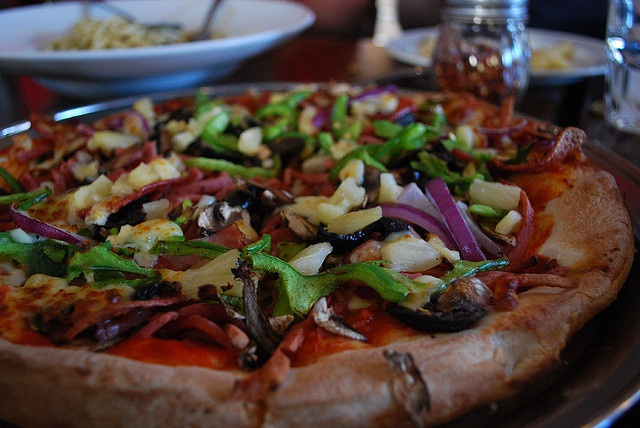Describe the objects in this image and their specific colors. I can see dining table in black, maroon, gray, and olive tones, pizza in black, maroon, olive, and gray tones, bowl in black, darkgray, and gray tones, cup in black, gray, and maroon tones, and cup in black, gray, navy, and darkblue tones in this image. 